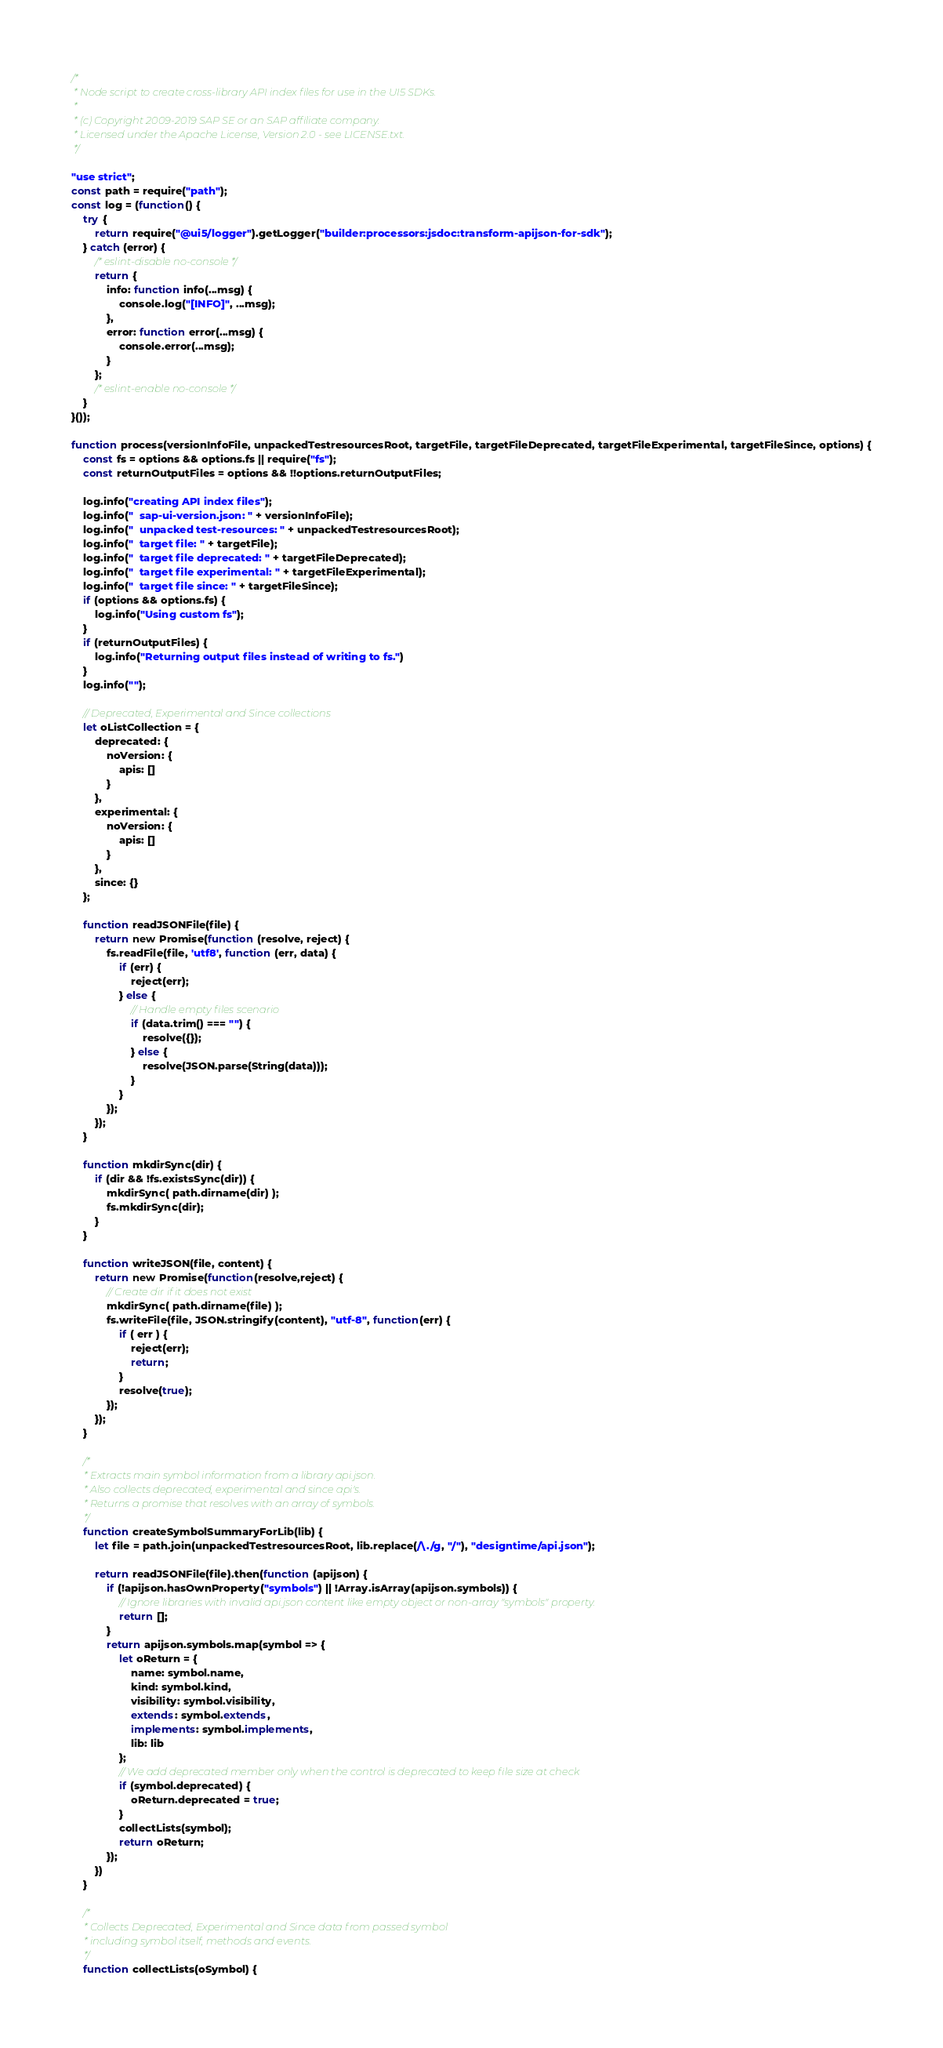<code> <loc_0><loc_0><loc_500><loc_500><_JavaScript_>/*
 * Node script to create cross-library API index files for use in the UI5 SDKs.
 *
 * (c) Copyright 2009-2019 SAP SE or an SAP affiliate company.
 * Licensed under the Apache License, Version 2.0 - see LICENSE.txt.
 */

"use strict";
const path = require("path");
const log = (function() {
	try {
		return require("@ui5/logger").getLogger("builder:processors:jsdoc:transform-apijson-for-sdk");
	} catch (error) {
		/* eslint-disable no-console */
		return {
			info: function info(...msg) {
				console.log("[INFO]", ...msg);
			},
			error: function error(...msg) {
				console.error(...msg);
			}
		};
		/* eslint-enable no-console */
	}
}());

function process(versionInfoFile, unpackedTestresourcesRoot, targetFile, targetFileDeprecated, targetFileExperimental, targetFileSince, options) {
	const fs = options && options.fs || require("fs");
	const returnOutputFiles = options && !!options.returnOutputFiles;

	log.info("creating API index files");
	log.info("  sap-ui-version.json: " + versionInfoFile);
	log.info("  unpacked test-resources: " + unpackedTestresourcesRoot);
	log.info("  target file: " + targetFile);
	log.info("  target file deprecated: " + targetFileDeprecated);
	log.info("  target file experimental: " + targetFileExperimental);
	log.info("  target file since: " + targetFileSince);
	if (options && options.fs) {
		log.info("Using custom fs");
	}
	if (returnOutputFiles) {
		log.info("Returning output files instead of writing to fs.")
	}
	log.info("");

	// Deprecated, Experimental and Since collections
	let oListCollection = {
		deprecated: {
			noVersion: {
				apis: []
			}
		},
		experimental: {
			noVersion: {
				apis: []
			}
		},
		since: {}
	};

	function readJSONFile(file) {
		return new Promise(function (resolve, reject) {
			fs.readFile(file, 'utf8', function (err, data) {
				if (err) {
					reject(err);
				} else {
					// Handle empty files scenario
					if (data.trim() === "") {
						resolve({});
					} else {
						resolve(JSON.parse(String(data)));
					}
				}
			});
		});
	}

	function mkdirSync(dir) {
		if (dir && !fs.existsSync(dir)) {
			mkdirSync( path.dirname(dir) );
			fs.mkdirSync(dir);
		}
	}

	function writeJSON(file, content) {
		return new Promise(function(resolve,reject) {
			// Create dir if it does not exist
			mkdirSync( path.dirname(file) );
			fs.writeFile(file, JSON.stringify(content), "utf-8", function(err) {
				if ( err ) {
					reject(err);
					return;
				}
				resolve(true);
			});
		});
	}

	/*
	 * Extracts main symbol information from a library api.json.
	 * Also collects deprecated, experimental and since api's.
	 * Returns a promise that resolves with an array of symbols.
	 */
	function createSymbolSummaryForLib(lib) {
		let file = path.join(unpackedTestresourcesRoot, lib.replace(/\./g, "/"), "designtime/api.json");

		return readJSONFile(file).then(function (apijson) {
			if (!apijson.hasOwnProperty("symbols") || !Array.isArray(apijson.symbols)) {
				// Ignore libraries with invalid api.json content like empty object or non-array "symbols" property.
				return [];
			}
			return apijson.symbols.map(symbol => {
				let oReturn = {
					name: symbol.name,
					kind: symbol.kind,
					visibility: symbol.visibility,
					extends: symbol.extends,
					implements: symbol.implements,
					lib: lib
				};
				// We add deprecated member only when the control is deprecated to keep file size at check
				if (symbol.deprecated) {
					oReturn.deprecated = true;
				}
				collectLists(symbol);
				return oReturn;
			});
		})
	}

	/*
	 * Collects Deprecated, Experimental and Since data from passed symbol
	 * including symbol itself, methods and events.
	 */
	function collectLists(oSymbol) {
</code> 